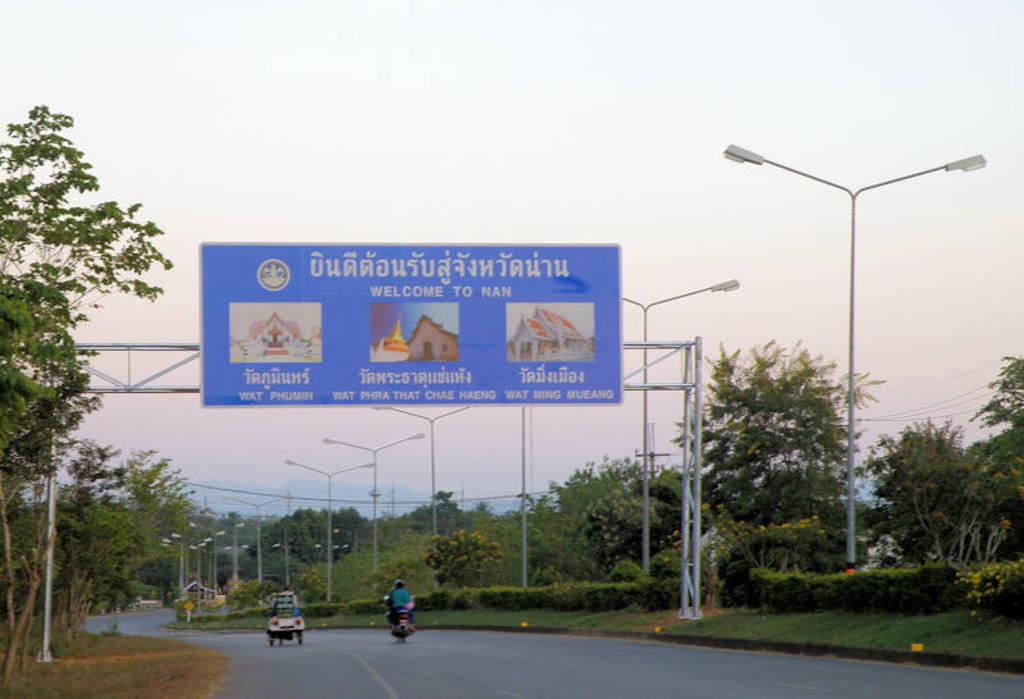What city is coming up?
Your answer should be very brief. Nan. What word comes before "to" on the sign?
Make the answer very short. Welcome. 